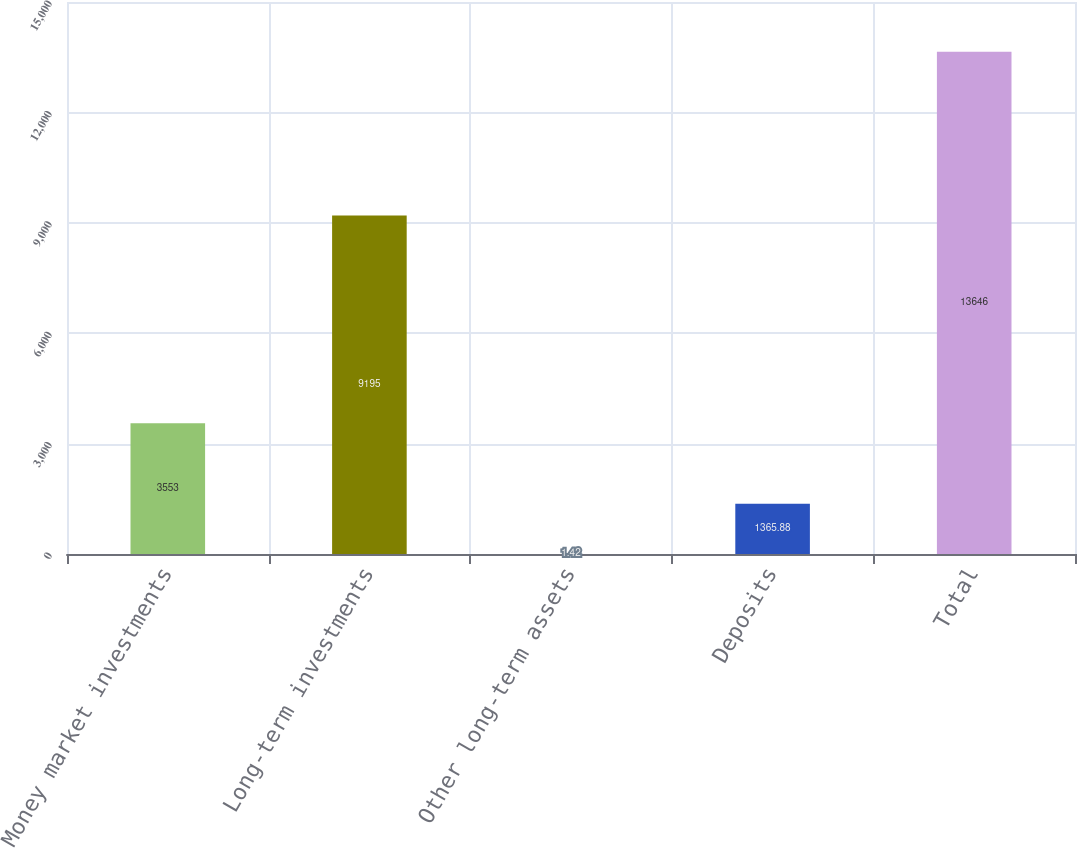Convert chart. <chart><loc_0><loc_0><loc_500><loc_500><bar_chart><fcel>Money market investments<fcel>Long-term investments<fcel>Other long-term assets<fcel>Deposits<fcel>Total<nl><fcel>3553<fcel>9195<fcel>1.42<fcel>1365.88<fcel>13646<nl></chart> 